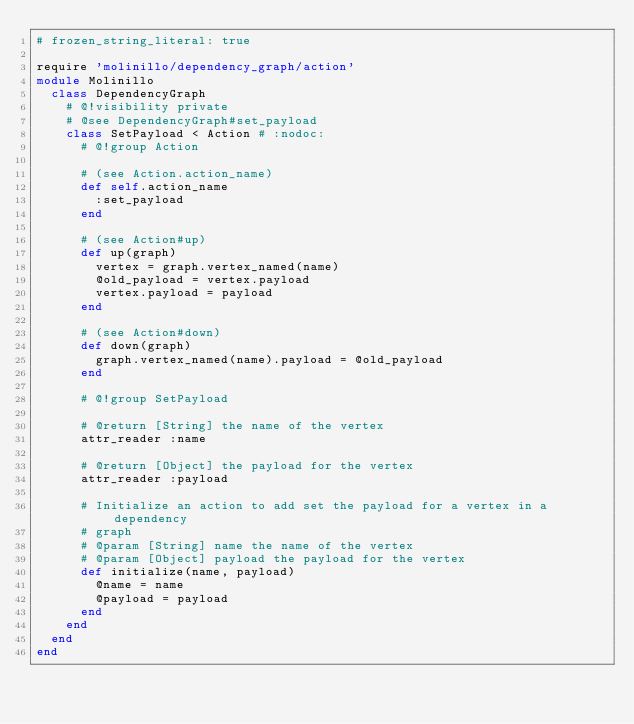<code> <loc_0><loc_0><loc_500><loc_500><_Ruby_># frozen_string_literal: true

require 'molinillo/dependency_graph/action'
module Molinillo
  class DependencyGraph
    # @!visibility private
    # @see DependencyGraph#set_payload
    class SetPayload < Action # :nodoc:
      # @!group Action

      # (see Action.action_name)
      def self.action_name
        :set_payload
      end

      # (see Action#up)
      def up(graph)
        vertex = graph.vertex_named(name)
        @old_payload = vertex.payload
        vertex.payload = payload
      end

      # (see Action#down)
      def down(graph)
        graph.vertex_named(name).payload = @old_payload
      end

      # @!group SetPayload

      # @return [String] the name of the vertex
      attr_reader :name

      # @return [Object] the payload for the vertex
      attr_reader :payload

      # Initialize an action to add set the payload for a vertex in a dependency
      # graph
      # @param [String] name the name of the vertex
      # @param [Object] payload the payload for the vertex
      def initialize(name, payload)
        @name = name
        @payload = payload
      end
    end
  end
end
</code> 